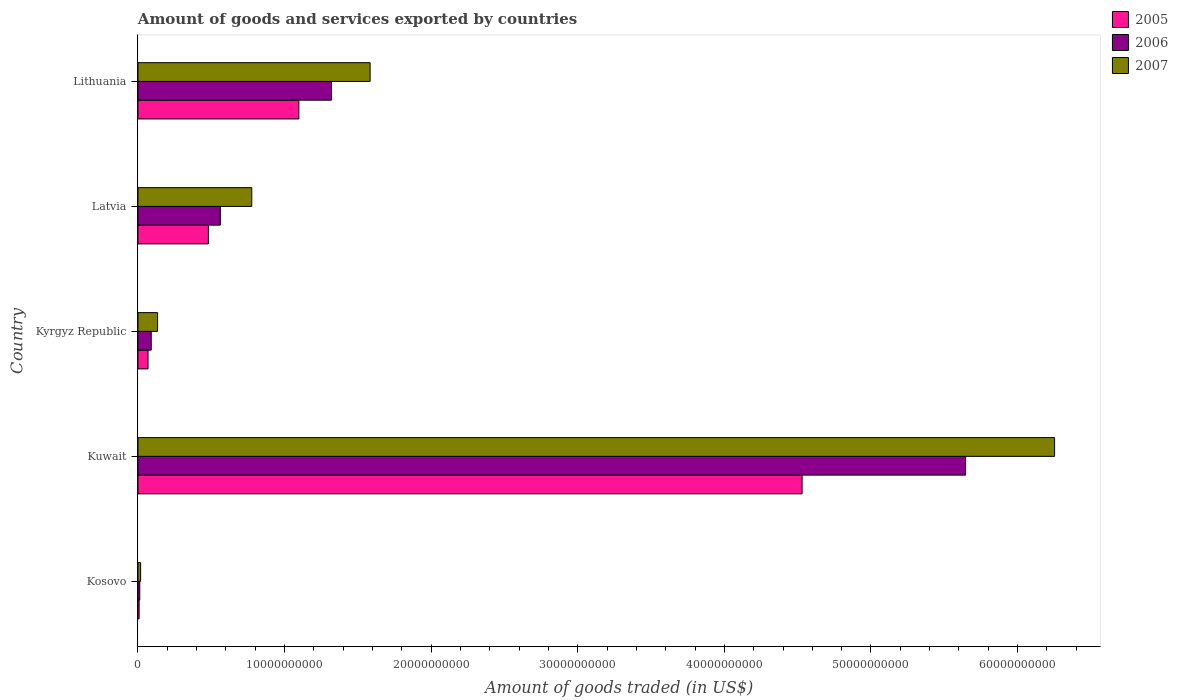How many different coloured bars are there?
Your response must be concise. 3. How many groups of bars are there?
Offer a terse response. 5. Are the number of bars on each tick of the Y-axis equal?
Offer a terse response. Yes. What is the label of the 3rd group of bars from the top?
Provide a succinct answer. Kyrgyz Republic. What is the total amount of goods and services exported in 2007 in Kosovo?
Offer a terse response. 1.82e+08. Across all countries, what is the maximum total amount of goods and services exported in 2005?
Give a very brief answer. 4.53e+1. Across all countries, what is the minimum total amount of goods and services exported in 2007?
Your answer should be very brief. 1.82e+08. In which country was the total amount of goods and services exported in 2005 maximum?
Keep it short and to the point. Kuwait. In which country was the total amount of goods and services exported in 2005 minimum?
Your answer should be compact. Kosovo. What is the total total amount of goods and services exported in 2006 in the graph?
Keep it short and to the point. 7.63e+1. What is the difference between the total amount of goods and services exported in 2007 in Kosovo and that in Kyrgyz Republic?
Your response must be concise. -1.16e+09. What is the difference between the total amount of goods and services exported in 2007 in Kyrgyz Republic and the total amount of goods and services exported in 2005 in Latvia?
Make the answer very short. -3.47e+09. What is the average total amount of goods and services exported in 2006 per country?
Provide a short and direct response. 1.53e+1. What is the difference between the total amount of goods and services exported in 2005 and total amount of goods and services exported in 2007 in Lithuania?
Your answer should be compact. -4.86e+09. What is the ratio of the total amount of goods and services exported in 2006 in Kosovo to that in Lithuania?
Provide a succinct answer. 0.01. What is the difference between the highest and the second highest total amount of goods and services exported in 2006?
Your answer should be very brief. 4.33e+1. What is the difference between the highest and the lowest total amount of goods and services exported in 2006?
Keep it short and to the point. 5.63e+1. In how many countries, is the total amount of goods and services exported in 2007 greater than the average total amount of goods and services exported in 2007 taken over all countries?
Offer a very short reply. 1. What does the 3rd bar from the top in Lithuania represents?
Your answer should be very brief. 2005. Is it the case that in every country, the sum of the total amount of goods and services exported in 2005 and total amount of goods and services exported in 2007 is greater than the total amount of goods and services exported in 2006?
Provide a succinct answer. Yes. Are all the bars in the graph horizontal?
Provide a succinct answer. Yes. What is the difference between two consecutive major ticks on the X-axis?
Offer a terse response. 1.00e+1. Are the values on the major ticks of X-axis written in scientific E-notation?
Ensure brevity in your answer.  No. Does the graph contain grids?
Offer a terse response. No. Where does the legend appear in the graph?
Offer a terse response. Top right. How many legend labels are there?
Give a very brief answer. 3. What is the title of the graph?
Give a very brief answer. Amount of goods and services exported by countries. Does "1989" appear as one of the legend labels in the graph?
Offer a very short reply. No. What is the label or title of the X-axis?
Offer a very short reply. Amount of goods traded (in US$). What is the label or title of the Y-axis?
Make the answer very short. Country. What is the Amount of goods traded (in US$) of 2005 in Kosovo?
Make the answer very short. 7.96e+07. What is the Amount of goods traded (in US$) in 2006 in Kosovo?
Give a very brief answer. 1.24e+08. What is the Amount of goods traded (in US$) in 2007 in Kosovo?
Offer a very short reply. 1.82e+08. What is the Amount of goods traded (in US$) of 2005 in Kuwait?
Keep it short and to the point. 4.53e+1. What is the Amount of goods traded (in US$) in 2006 in Kuwait?
Your response must be concise. 5.65e+1. What is the Amount of goods traded (in US$) of 2007 in Kuwait?
Your answer should be compact. 6.25e+1. What is the Amount of goods traded (in US$) of 2005 in Kyrgyz Republic?
Keep it short and to the point. 6.87e+08. What is the Amount of goods traded (in US$) in 2006 in Kyrgyz Republic?
Give a very brief answer. 9.06e+08. What is the Amount of goods traded (in US$) in 2007 in Kyrgyz Republic?
Give a very brief answer. 1.34e+09. What is the Amount of goods traded (in US$) in 2005 in Latvia?
Ensure brevity in your answer.  4.80e+09. What is the Amount of goods traded (in US$) in 2006 in Latvia?
Make the answer very short. 5.62e+09. What is the Amount of goods traded (in US$) of 2007 in Latvia?
Offer a terse response. 7.76e+09. What is the Amount of goods traded (in US$) in 2005 in Lithuania?
Offer a very short reply. 1.10e+1. What is the Amount of goods traded (in US$) of 2006 in Lithuania?
Provide a short and direct response. 1.32e+1. What is the Amount of goods traded (in US$) in 2007 in Lithuania?
Keep it short and to the point. 1.58e+1. Across all countries, what is the maximum Amount of goods traded (in US$) of 2005?
Ensure brevity in your answer.  4.53e+1. Across all countries, what is the maximum Amount of goods traded (in US$) in 2006?
Your answer should be compact. 5.65e+1. Across all countries, what is the maximum Amount of goods traded (in US$) of 2007?
Your response must be concise. 6.25e+1. Across all countries, what is the minimum Amount of goods traded (in US$) of 2005?
Provide a succinct answer. 7.96e+07. Across all countries, what is the minimum Amount of goods traded (in US$) of 2006?
Offer a terse response. 1.24e+08. Across all countries, what is the minimum Amount of goods traded (in US$) of 2007?
Your answer should be compact. 1.82e+08. What is the total Amount of goods traded (in US$) of 2005 in the graph?
Offer a terse response. 6.18e+1. What is the total Amount of goods traded (in US$) of 2006 in the graph?
Ensure brevity in your answer.  7.63e+1. What is the total Amount of goods traded (in US$) in 2007 in the graph?
Your answer should be compact. 8.76e+1. What is the difference between the Amount of goods traded (in US$) in 2005 in Kosovo and that in Kuwait?
Offer a terse response. -4.52e+1. What is the difference between the Amount of goods traded (in US$) in 2006 in Kosovo and that in Kuwait?
Provide a succinct answer. -5.63e+1. What is the difference between the Amount of goods traded (in US$) in 2007 in Kosovo and that in Kuwait?
Your response must be concise. -6.23e+1. What is the difference between the Amount of goods traded (in US$) of 2005 in Kosovo and that in Kyrgyz Republic?
Offer a terse response. -6.07e+08. What is the difference between the Amount of goods traded (in US$) in 2006 in Kosovo and that in Kyrgyz Republic?
Your response must be concise. -7.82e+08. What is the difference between the Amount of goods traded (in US$) of 2007 in Kosovo and that in Kyrgyz Republic?
Offer a terse response. -1.16e+09. What is the difference between the Amount of goods traded (in US$) in 2005 in Kosovo and that in Latvia?
Give a very brief answer. -4.73e+09. What is the difference between the Amount of goods traded (in US$) of 2006 in Kosovo and that in Latvia?
Offer a very short reply. -5.50e+09. What is the difference between the Amount of goods traded (in US$) of 2007 in Kosovo and that in Latvia?
Provide a short and direct response. -7.58e+09. What is the difference between the Amount of goods traded (in US$) of 2005 in Kosovo and that in Lithuania?
Provide a succinct answer. -1.09e+1. What is the difference between the Amount of goods traded (in US$) of 2006 in Kosovo and that in Lithuania?
Ensure brevity in your answer.  -1.31e+1. What is the difference between the Amount of goods traded (in US$) of 2007 in Kosovo and that in Lithuania?
Ensure brevity in your answer.  -1.57e+1. What is the difference between the Amount of goods traded (in US$) of 2005 in Kuwait and that in Kyrgyz Republic?
Ensure brevity in your answer.  4.46e+1. What is the difference between the Amount of goods traded (in US$) of 2006 in Kuwait and that in Kyrgyz Republic?
Your response must be concise. 5.55e+1. What is the difference between the Amount of goods traded (in US$) of 2007 in Kuwait and that in Kyrgyz Republic?
Give a very brief answer. 6.12e+1. What is the difference between the Amount of goods traded (in US$) of 2005 in Kuwait and that in Latvia?
Your response must be concise. 4.05e+1. What is the difference between the Amount of goods traded (in US$) of 2006 in Kuwait and that in Latvia?
Provide a succinct answer. 5.08e+1. What is the difference between the Amount of goods traded (in US$) in 2007 in Kuwait and that in Latvia?
Make the answer very short. 5.48e+1. What is the difference between the Amount of goods traded (in US$) in 2005 in Kuwait and that in Lithuania?
Provide a short and direct response. 3.43e+1. What is the difference between the Amount of goods traded (in US$) in 2006 in Kuwait and that in Lithuania?
Give a very brief answer. 4.33e+1. What is the difference between the Amount of goods traded (in US$) of 2007 in Kuwait and that in Lithuania?
Provide a succinct answer. 4.67e+1. What is the difference between the Amount of goods traded (in US$) in 2005 in Kyrgyz Republic and that in Latvia?
Make the answer very short. -4.12e+09. What is the difference between the Amount of goods traded (in US$) of 2006 in Kyrgyz Republic and that in Latvia?
Provide a short and direct response. -4.71e+09. What is the difference between the Amount of goods traded (in US$) in 2007 in Kyrgyz Republic and that in Latvia?
Ensure brevity in your answer.  -6.42e+09. What is the difference between the Amount of goods traded (in US$) in 2005 in Kyrgyz Republic and that in Lithuania?
Offer a terse response. -1.03e+1. What is the difference between the Amount of goods traded (in US$) in 2006 in Kyrgyz Republic and that in Lithuania?
Your response must be concise. -1.23e+1. What is the difference between the Amount of goods traded (in US$) in 2007 in Kyrgyz Republic and that in Lithuania?
Provide a short and direct response. -1.45e+1. What is the difference between the Amount of goods traded (in US$) in 2005 in Latvia and that in Lithuania?
Provide a short and direct response. -6.17e+09. What is the difference between the Amount of goods traded (in US$) in 2006 in Latvia and that in Lithuania?
Offer a terse response. -7.58e+09. What is the difference between the Amount of goods traded (in US$) in 2007 in Latvia and that in Lithuania?
Your answer should be very brief. -8.07e+09. What is the difference between the Amount of goods traded (in US$) of 2005 in Kosovo and the Amount of goods traded (in US$) of 2006 in Kuwait?
Your answer should be very brief. -5.64e+1. What is the difference between the Amount of goods traded (in US$) in 2005 in Kosovo and the Amount of goods traded (in US$) in 2007 in Kuwait?
Provide a succinct answer. -6.24e+1. What is the difference between the Amount of goods traded (in US$) in 2006 in Kosovo and the Amount of goods traded (in US$) in 2007 in Kuwait?
Your answer should be compact. -6.24e+1. What is the difference between the Amount of goods traded (in US$) of 2005 in Kosovo and the Amount of goods traded (in US$) of 2006 in Kyrgyz Republic?
Offer a terse response. -8.26e+08. What is the difference between the Amount of goods traded (in US$) in 2005 in Kosovo and the Amount of goods traded (in US$) in 2007 in Kyrgyz Republic?
Offer a very short reply. -1.26e+09. What is the difference between the Amount of goods traded (in US$) in 2006 in Kosovo and the Amount of goods traded (in US$) in 2007 in Kyrgyz Republic?
Provide a succinct answer. -1.21e+09. What is the difference between the Amount of goods traded (in US$) of 2005 in Kosovo and the Amount of goods traded (in US$) of 2006 in Latvia?
Your answer should be very brief. -5.54e+09. What is the difference between the Amount of goods traded (in US$) of 2005 in Kosovo and the Amount of goods traded (in US$) of 2007 in Latvia?
Keep it short and to the point. -7.68e+09. What is the difference between the Amount of goods traded (in US$) of 2006 in Kosovo and the Amount of goods traded (in US$) of 2007 in Latvia?
Your answer should be very brief. -7.64e+09. What is the difference between the Amount of goods traded (in US$) in 2005 in Kosovo and the Amount of goods traded (in US$) in 2006 in Lithuania?
Give a very brief answer. -1.31e+1. What is the difference between the Amount of goods traded (in US$) of 2005 in Kosovo and the Amount of goods traded (in US$) of 2007 in Lithuania?
Make the answer very short. -1.58e+1. What is the difference between the Amount of goods traded (in US$) of 2006 in Kosovo and the Amount of goods traded (in US$) of 2007 in Lithuania?
Offer a very short reply. -1.57e+1. What is the difference between the Amount of goods traded (in US$) in 2005 in Kuwait and the Amount of goods traded (in US$) in 2006 in Kyrgyz Republic?
Your answer should be compact. 4.44e+1. What is the difference between the Amount of goods traded (in US$) in 2005 in Kuwait and the Amount of goods traded (in US$) in 2007 in Kyrgyz Republic?
Ensure brevity in your answer.  4.40e+1. What is the difference between the Amount of goods traded (in US$) of 2006 in Kuwait and the Amount of goods traded (in US$) of 2007 in Kyrgyz Republic?
Your response must be concise. 5.51e+1. What is the difference between the Amount of goods traded (in US$) in 2005 in Kuwait and the Amount of goods traded (in US$) in 2006 in Latvia?
Your answer should be compact. 3.97e+1. What is the difference between the Amount of goods traded (in US$) of 2005 in Kuwait and the Amount of goods traded (in US$) of 2007 in Latvia?
Offer a terse response. 3.75e+1. What is the difference between the Amount of goods traded (in US$) in 2006 in Kuwait and the Amount of goods traded (in US$) in 2007 in Latvia?
Your answer should be compact. 4.87e+1. What is the difference between the Amount of goods traded (in US$) in 2005 in Kuwait and the Amount of goods traded (in US$) in 2006 in Lithuania?
Offer a very short reply. 3.21e+1. What is the difference between the Amount of goods traded (in US$) in 2005 in Kuwait and the Amount of goods traded (in US$) in 2007 in Lithuania?
Give a very brief answer. 2.95e+1. What is the difference between the Amount of goods traded (in US$) in 2006 in Kuwait and the Amount of goods traded (in US$) in 2007 in Lithuania?
Ensure brevity in your answer.  4.06e+1. What is the difference between the Amount of goods traded (in US$) in 2005 in Kyrgyz Republic and the Amount of goods traded (in US$) in 2006 in Latvia?
Your answer should be compact. -4.93e+09. What is the difference between the Amount of goods traded (in US$) in 2005 in Kyrgyz Republic and the Amount of goods traded (in US$) in 2007 in Latvia?
Ensure brevity in your answer.  -7.08e+09. What is the difference between the Amount of goods traded (in US$) in 2006 in Kyrgyz Republic and the Amount of goods traded (in US$) in 2007 in Latvia?
Give a very brief answer. -6.86e+09. What is the difference between the Amount of goods traded (in US$) in 2005 in Kyrgyz Republic and the Amount of goods traded (in US$) in 2006 in Lithuania?
Keep it short and to the point. -1.25e+1. What is the difference between the Amount of goods traded (in US$) of 2005 in Kyrgyz Republic and the Amount of goods traded (in US$) of 2007 in Lithuania?
Your answer should be very brief. -1.51e+1. What is the difference between the Amount of goods traded (in US$) of 2006 in Kyrgyz Republic and the Amount of goods traded (in US$) of 2007 in Lithuania?
Give a very brief answer. -1.49e+1. What is the difference between the Amount of goods traded (in US$) of 2005 in Latvia and the Amount of goods traded (in US$) of 2006 in Lithuania?
Your answer should be compact. -8.40e+09. What is the difference between the Amount of goods traded (in US$) of 2005 in Latvia and the Amount of goods traded (in US$) of 2007 in Lithuania?
Your response must be concise. -1.10e+1. What is the difference between the Amount of goods traded (in US$) in 2006 in Latvia and the Amount of goods traded (in US$) in 2007 in Lithuania?
Provide a succinct answer. -1.02e+1. What is the average Amount of goods traded (in US$) of 2005 per country?
Offer a very short reply. 1.24e+1. What is the average Amount of goods traded (in US$) of 2006 per country?
Keep it short and to the point. 1.53e+1. What is the average Amount of goods traded (in US$) of 2007 per country?
Keep it short and to the point. 1.75e+1. What is the difference between the Amount of goods traded (in US$) of 2005 and Amount of goods traded (in US$) of 2006 in Kosovo?
Make the answer very short. -4.40e+07. What is the difference between the Amount of goods traded (in US$) of 2005 and Amount of goods traded (in US$) of 2007 in Kosovo?
Keep it short and to the point. -1.02e+08. What is the difference between the Amount of goods traded (in US$) in 2006 and Amount of goods traded (in US$) in 2007 in Kosovo?
Offer a terse response. -5.80e+07. What is the difference between the Amount of goods traded (in US$) of 2005 and Amount of goods traded (in US$) of 2006 in Kuwait?
Your answer should be compact. -1.12e+1. What is the difference between the Amount of goods traded (in US$) in 2005 and Amount of goods traded (in US$) in 2007 in Kuwait?
Give a very brief answer. -1.72e+1. What is the difference between the Amount of goods traded (in US$) of 2006 and Amount of goods traded (in US$) of 2007 in Kuwait?
Make the answer very short. -6.07e+09. What is the difference between the Amount of goods traded (in US$) in 2005 and Amount of goods traded (in US$) in 2006 in Kyrgyz Republic?
Make the answer very short. -2.19e+08. What is the difference between the Amount of goods traded (in US$) of 2005 and Amount of goods traded (in US$) of 2007 in Kyrgyz Republic?
Your answer should be very brief. -6.51e+08. What is the difference between the Amount of goods traded (in US$) of 2006 and Amount of goods traded (in US$) of 2007 in Kyrgyz Republic?
Keep it short and to the point. -4.32e+08. What is the difference between the Amount of goods traded (in US$) of 2005 and Amount of goods traded (in US$) of 2006 in Latvia?
Your answer should be very brief. -8.14e+08. What is the difference between the Amount of goods traded (in US$) of 2005 and Amount of goods traded (in US$) of 2007 in Latvia?
Provide a succinct answer. -2.96e+09. What is the difference between the Amount of goods traded (in US$) of 2006 and Amount of goods traded (in US$) of 2007 in Latvia?
Offer a terse response. -2.14e+09. What is the difference between the Amount of goods traded (in US$) in 2005 and Amount of goods traded (in US$) in 2006 in Lithuania?
Give a very brief answer. -2.23e+09. What is the difference between the Amount of goods traded (in US$) of 2005 and Amount of goods traded (in US$) of 2007 in Lithuania?
Provide a succinct answer. -4.86e+09. What is the difference between the Amount of goods traded (in US$) in 2006 and Amount of goods traded (in US$) in 2007 in Lithuania?
Your answer should be compact. -2.64e+09. What is the ratio of the Amount of goods traded (in US$) of 2005 in Kosovo to that in Kuwait?
Provide a succinct answer. 0. What is the ratio of the Amount of goods traded (in US$) in 2006 in Kosovo to that in Kuwait?
Offer a very short reply. 0. What is the ratio of the Amount of goods traded (in US$) of 2007 in Kosovo to that in Kuwait?
Offer a very short reply. 0. What is the ratio of the Amount of goods traded (in US$) in 2005 in Kosovo to that in Kyrgyz Republic?
Provide a short and direct response. 0.12. What is the ratio of the Amount of goods traded (in US$) in 2006 in Kosovo to that in Kyrgyz Republic?
Provide a succinct answer. 0.14. What is the ratio of the Amount of goods traded (in US$) of 2007 in Kosovo to that in Kyrgyz Republic?
Make the answer very short. 0.14. What is the ratio of the Amount of goods traded (in US$) of 2005 in Kosovo to that in Latvia?
Keep it short and to the point. 0.02. What is the ratio of the Amount of goods traded (in US$) in 2006 in Kosovo to that in Latvia?
Provide a short and direct response. 0.02. What is the ratio of the Amount of goods traded (in US$) in 2007 in Kosovo to that in Latvia?
Keep it short and to the point. 0.02. What is the ratio of the Amount of goods traded (in US$) in 2005 in Kosovo to that in Lithuania?
Give a very brief answer. 0.01. What is the ratio of the Amount of goods traded (in US$) of 2006 in Kosovo to that in Lithuania?
Your answer should be compact. 0.01. What is the ratio of the Amount of goods traded (in US$) in 2007 in Kosovo to that in Lithuania?
Your answer should be compact. 0.01. What is the ratio of the Amount of goods traded (in US$) in 2005 in Kuwait to that in Kyrgyz Republic?
Make the answer very short. 65.96. What is the ratio of the Amount of goods traded (in US$) in 2006 in Kuwait to that in Kyrgyz Republic?
Offer a terse response. 62.31. What is the ratio of the Amount of goods traded (in US$) of 2007 in Kuwait to that in Kyrgyz Republic?
Ensure brevity in your answer.  46.74. What is the ratio of the Amount of goods traded (in US$) in 2005 in Kuwait to that in Latvia?
Offer a terse response. 9.43. What is the ratio of the Amount of goods traded (in US$) of 2006 in Kuwait to that in Latvia?
Offer a terse response. 10.05. What is the ratio of the Amount of goods traded (in US$) in 2007 in Kuwait to that in Latvia?
Offer a very short reply. 8.05. What is the ratio of the Amount of goods traded (in US$) of 2005 in Kuwait to that in Lithuania?
Your response must be concise. 4.13. What is the ratio of the Amount of goods traded (in US$) of 2006 in Kuwait to that in Lithuania?
Give a very brief answer. 4.28. What is the ratio of the Amount of goods traded (in US$) in 2007 in Kuwait to that in Lithuania?
Provide a succinct answer. 3.95. What is the ratio of the Amount of goods traded (in US$) in 2005 in Kyrgyz Republic to that in Latvia?
Provide a short and direct response. 0.14. What is the ratio of the Amount of goods traded (in US$) in 2006 in Kyrgyz Republic to that in Latvia?
Make the answer very short. 0.16. What is the ratio of the Amount of goods traded (in US$) in 2007 in Kyrgyz Republic to that in Latvia?
Give a very brief answer. 0.17. What is the ratio of the Amount of goods traded (in US$) of 2005 in Kyrgyz Republic to that in Lithuania?
Your answer should be compact. 0.06. What is the ratio of the Amount of goods traded (in US$) in 2006 in Kyrgyz Republic to that in Lithuania?
Offer a very short reply. 0.07. What is the ratio of the Amount of goods traded (in US$) of 2007 in Kyrgyz Republic to that in Lithuania?
Your answer should be compact. 0.08. What is the ratio of the Amount of goods traded (in US$) of 2005 in Latvia to that in Lithuania?
Give a very brief answer. 0.44. What is the ratio of the Amount of goods traded (in US$) in 2006 in Latvia to that in Lithuania?
Keep it short and to the point. 0.43. What is the ratio of the Amount of goods traded (in US$) of 2007 in Latvia to that in Lithuania?
Keep it short and to the point. 0.49. What is the difference between the highest and the second highest Amount of goods traded (in US$) of 2005?
Make the answer very short. 3.43e+1. What is the difference between the highest and the second highest Amount of goods traded (in US$) in 2006?
Ensure brevity in your answer.  4.33e+1. What is the difference between the highest and the second highest Amount of goods traded (in US$) of 2007?
Keep it short and to the point. 4.67e+1. What is the difference between the highest and the lowest Amount of goods traded (in US$) in 2005?
Keep it short and to the point. 4.52e+1. What is the difference between the highest and the lowest Amount of goods traded (in US$) in 2006?
Offer a terse response. 5.63e+1. What is the difference between the highest and the lowest Amount of goods traded (in US$) of 2007?
Your answer should be very brief. 6.23e+1. 